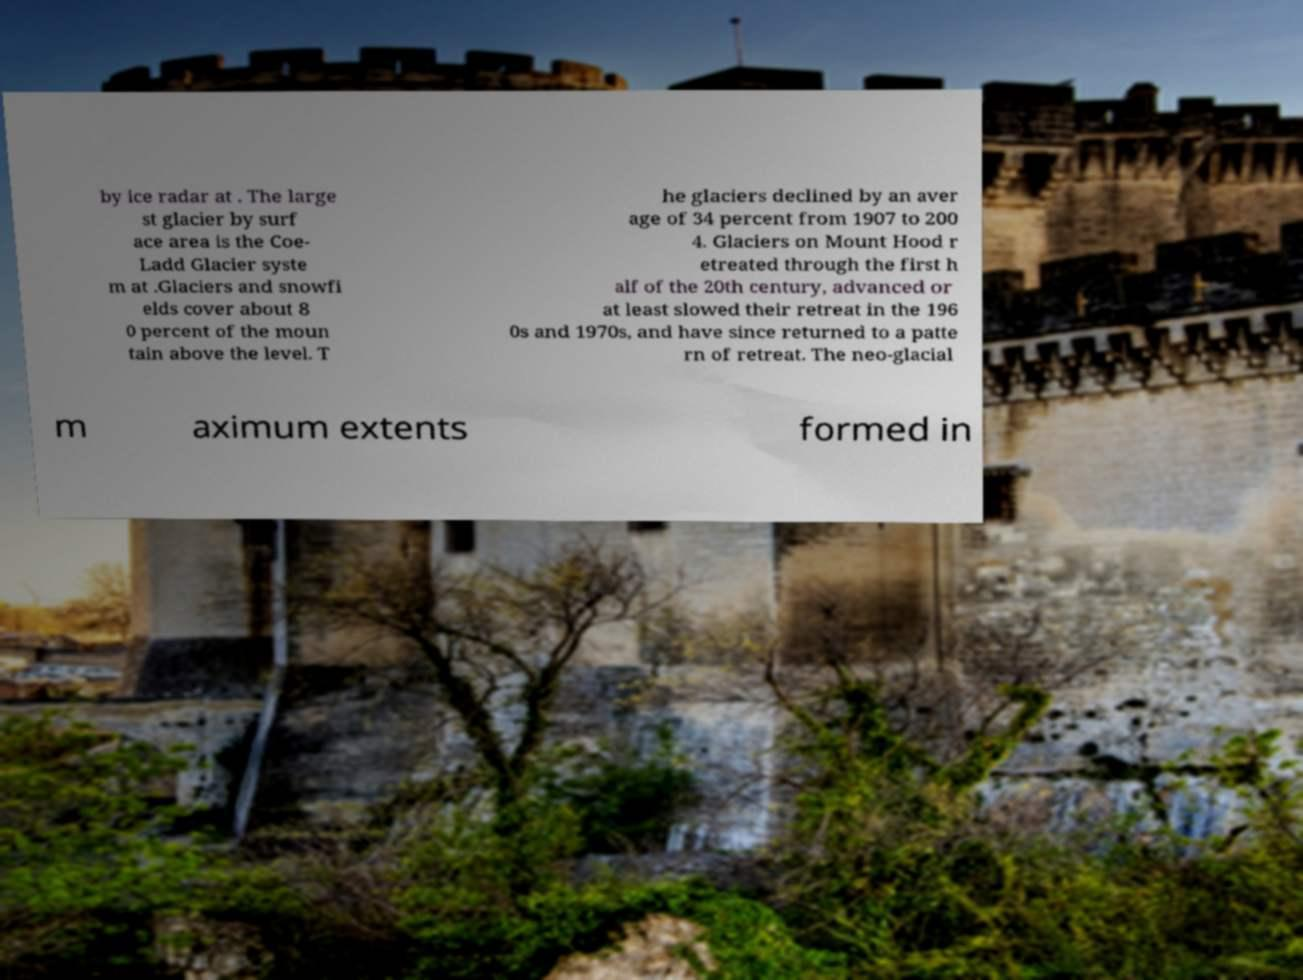Please identify and transcribe the text found in this image. by ice radar at . The large st glacier by surf ace area is the Coe- Ladd Glacier syste m at .Glaciers and snowfi elds cover about 8 0 percent of the moun tain above the level. T he glaciers declined by an aver age of 34 percent from 1907 to 200 4. Glaciers on Mount Hood r etreated through the first h alf of the 20th century, advanced or at least slowed their retreat in the 196 0s and 1970s, and have since returned to a patte rn of retreat. The neo-glacial m aximum extents formed in 